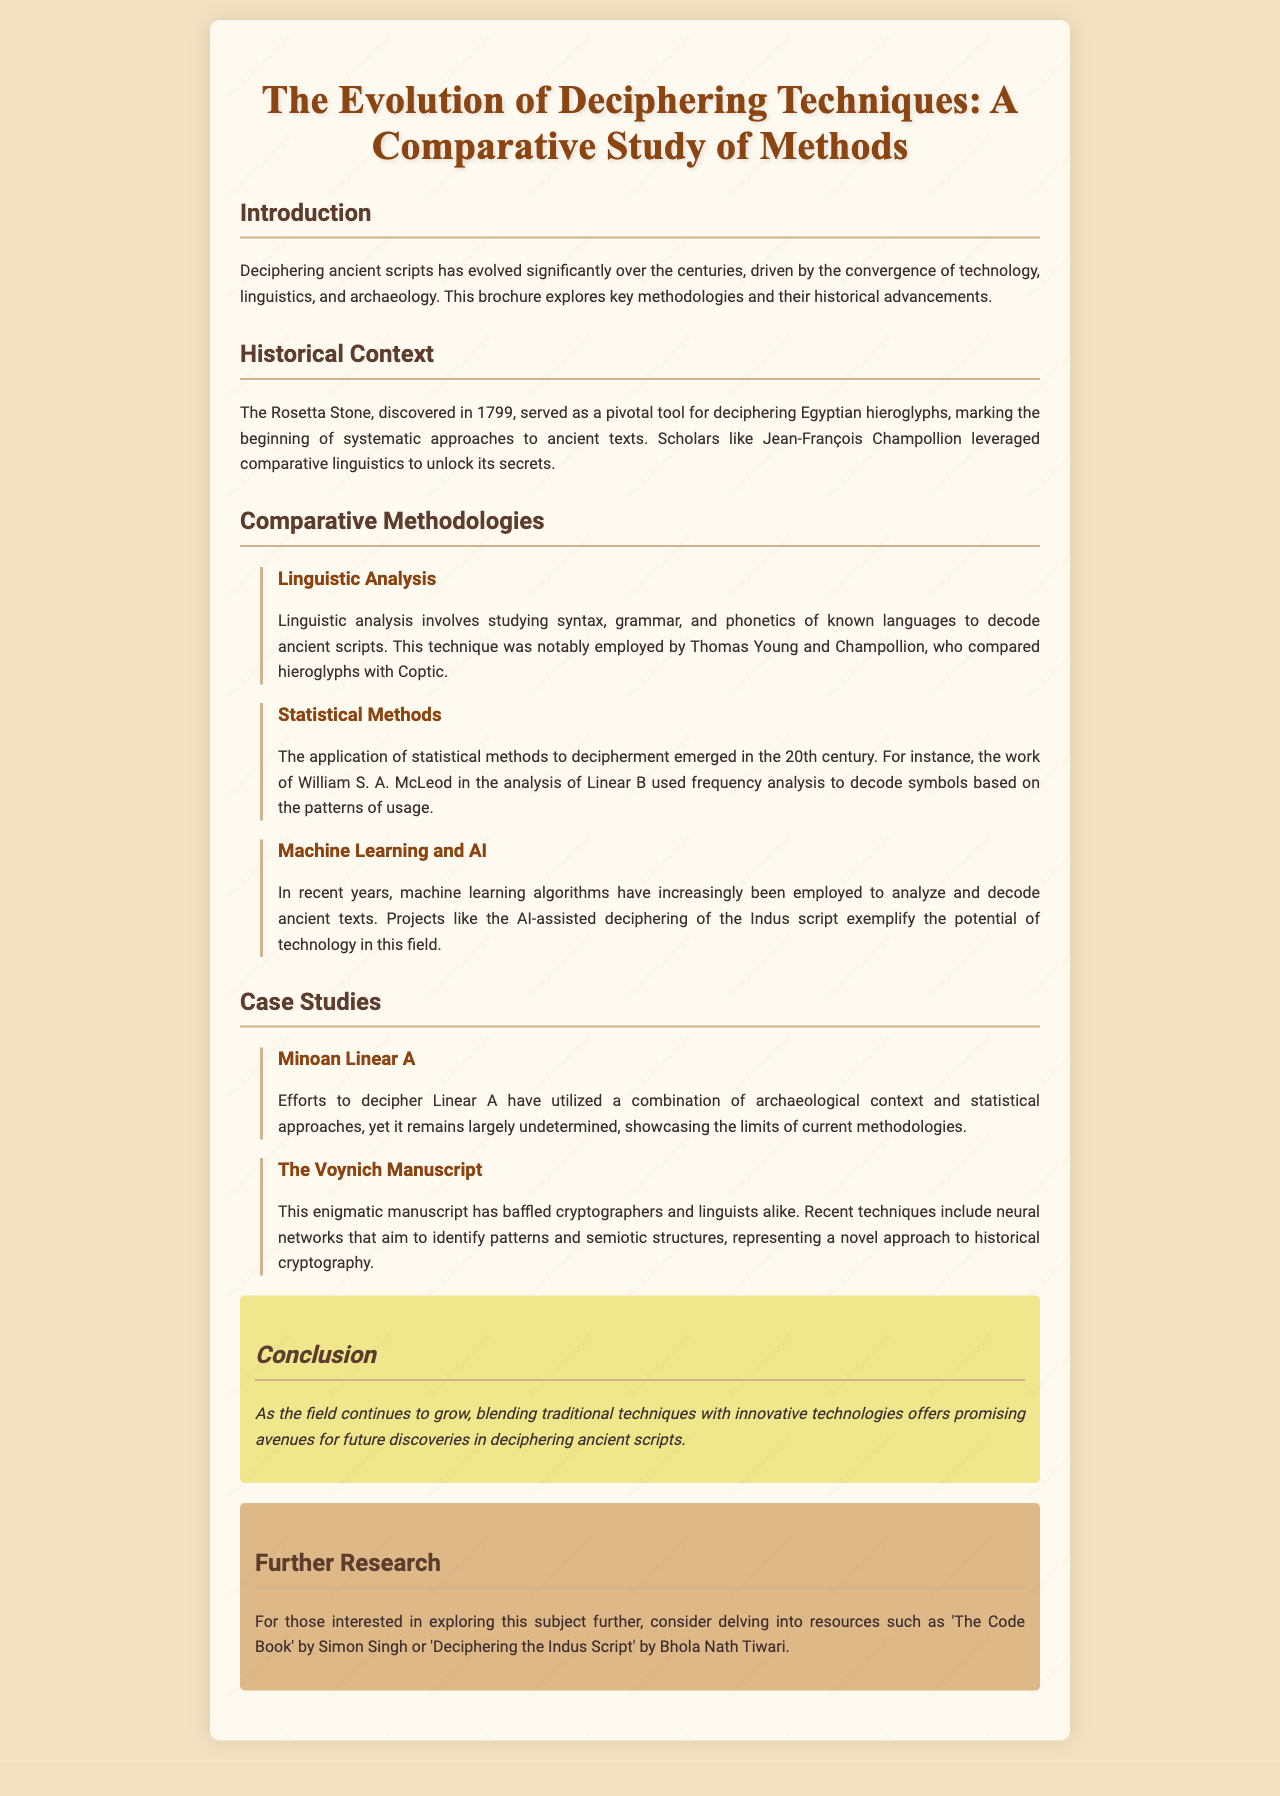What year was the Rosetta Stone discovered? The document states that the Rosetta Stone was discovered in 1799.
Answer: 1799 Who primarily leveraged comparative linguistics for deciphering hieroglyphs? According to the document, Jean-François Champollion was a key figure in leveraging comparative linguistics.
Answer: Jean-François Champollion What is a technique used in the analysis of Linear B? The document mentions that frequency analysis was used in the analysis of Linear B.
Answer: Frequency analysis Which manuscripts have baffled cryptographers and linguists? The document specifically refers to the Voynich Manuscript as having baffled cryptographers and linguists.
Answer: The Voynich Manuscript What recent approach is mentioned for decrypting the Indus script? The document describes the use of machine learning algorithms in the AI-assisted deciphering of the Indus script.
Answer: Machine learning algorithms How does the document categorize the section on deciphering methodologies? The section on deciphering methodologies is categorized into subsections, such as Linguistic Analysis, Statistical Methods, and Machine Learning and AI.
Answer: Comparative Methodologies What book is recommended for further research? The document suggests 'The Code Book' by Simon Singh for further research.
Answer: The Code Book What major theme is discussed in the conclusion of the document? The conclusion emphasizes blending traditional techniques with innovative technologies in the field of deciphering ancient scripts.
Answer: Blending traditional techniques with innovative technologies 